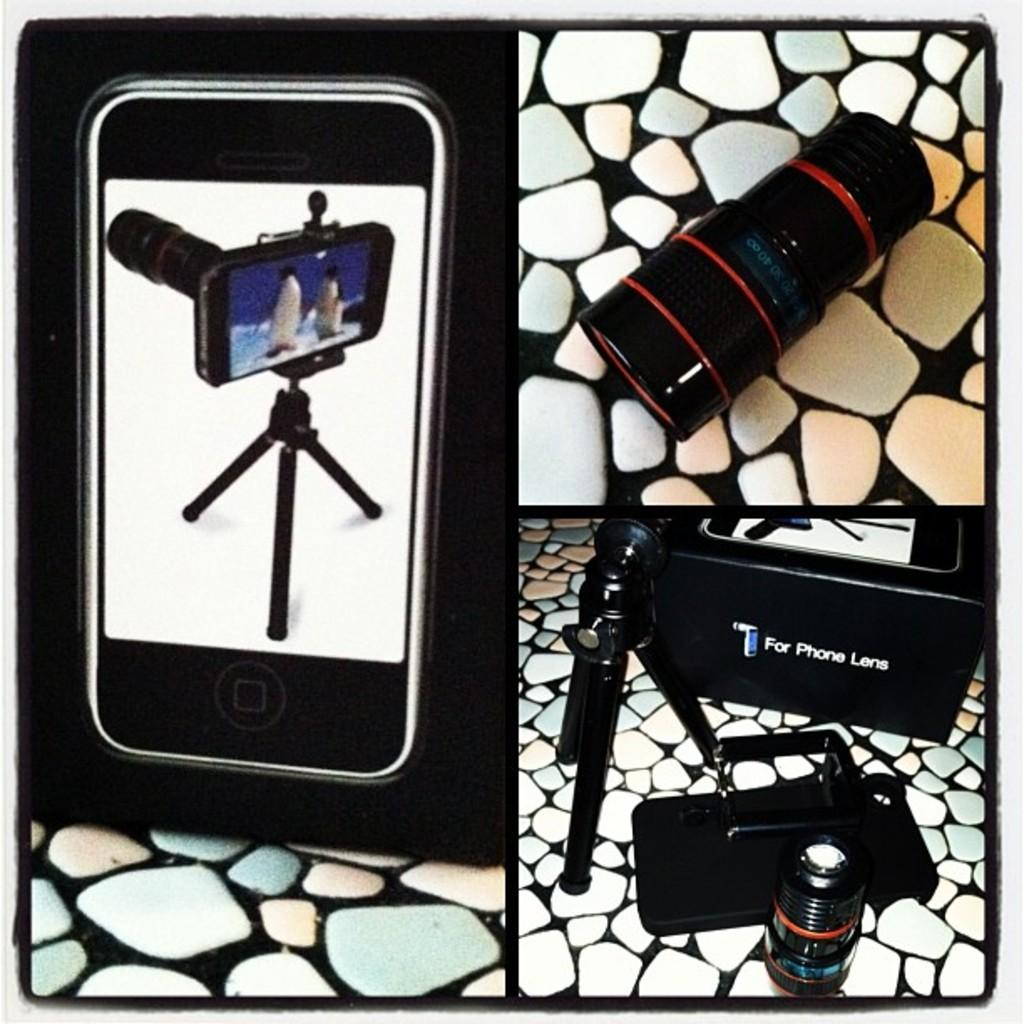What type of image is shown in the collage? The image is a collage. What is one of the objects featured in the collage? There is a mobile box in the image. Can you identify any other objects in the collage? Yes, there is a lens, a stand, and a bag in the image. What is the surface on which the objects are placed? The objects are on a marble floor. What type of button is used to control the sail in the image? There is no button or sail present in the image; it features a collage of various objects. What part of the image is responsible for the sail's movement? There is no sail or movement in the image, as it is a still collage of objects. 